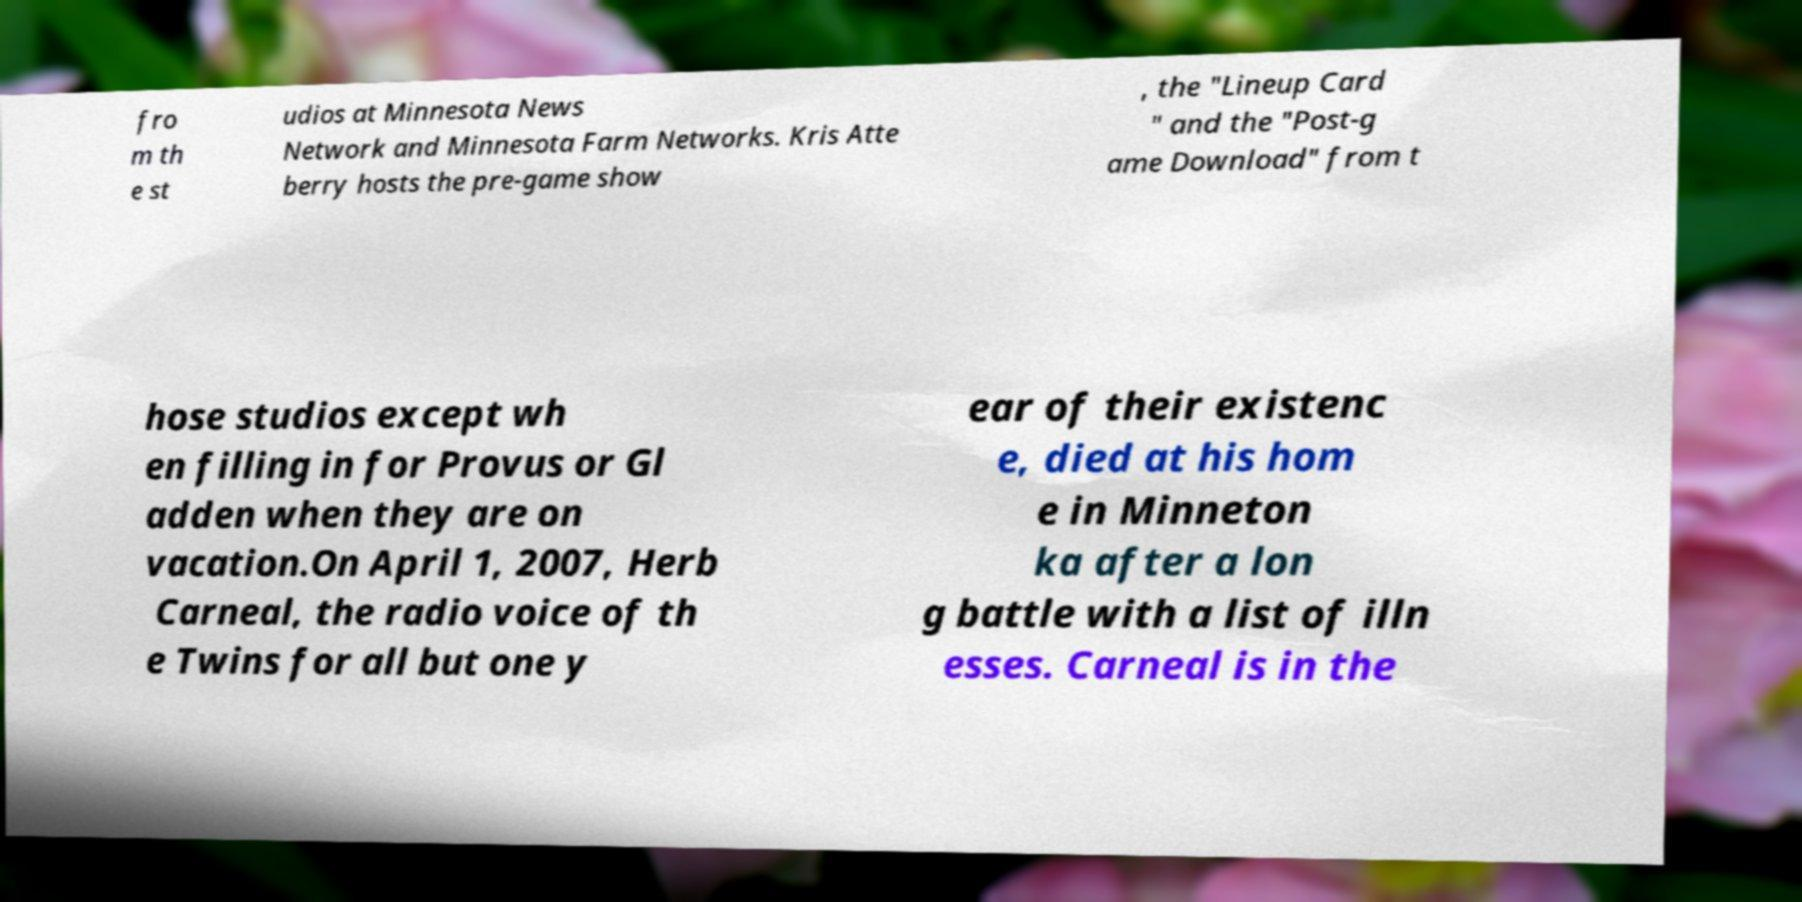Could you assist in decoding the text presented in this image and type it out clearly? fro m th e st udios at Minnesota News Network and Minnesota Farm Networks. Kris Atte berry hosts the pre-game show , the "Lineup Card " and the "Post-g ame Download" from t hose studios except wh en filling in for Provus or Gl adden when they are on vacation.On April 1, 2007, Herb Carneal, the radio voice of th e Twins for all but one y ear of their existenc e, died at his hom e in Minneton ka after a lon g battle with a list of illn esses. Carneal is in the 